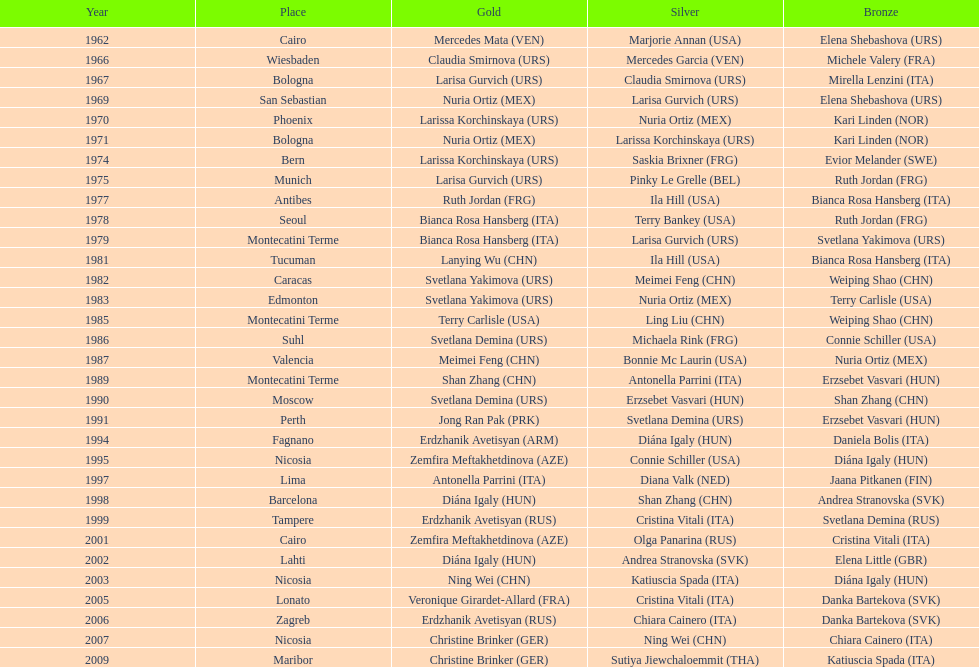How many gold did u.s.a win 1. 